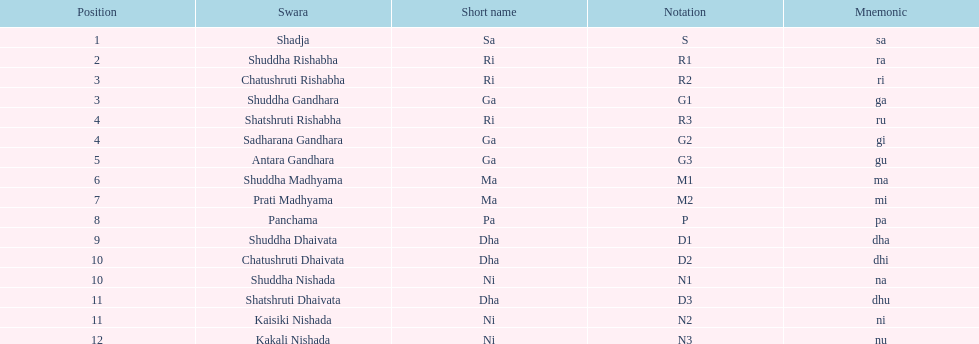How many swara typically have short names that start with the letter d or g on average? 6. 